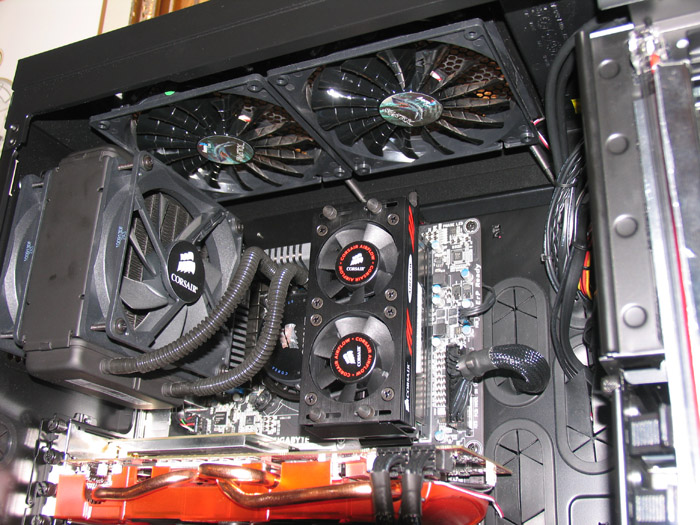For a home-based data scientist, what aspects of this setup would be most beneficial for their work? For a home-based data scientist, this setup offers numerous beneficial aspects. The high-performance GPU would be instrumental in accelerating machine learning models and data analysis tasks, significantly reducing processing time. The cooling system ensures the machine runs efficiently under extended workloads, preventing overheating during long computational tasks. Additionally, the likely inclusion of high-speed storage solutions would optimize data management, providing faster access to large datasets. Together, these components create an environment conducive to intensive data science work, offering both speed and reliability. 